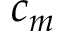Convert formula to latex. <formula><loc_0><loc_0><loc_500><loc_500>c _ { m }</formula> 